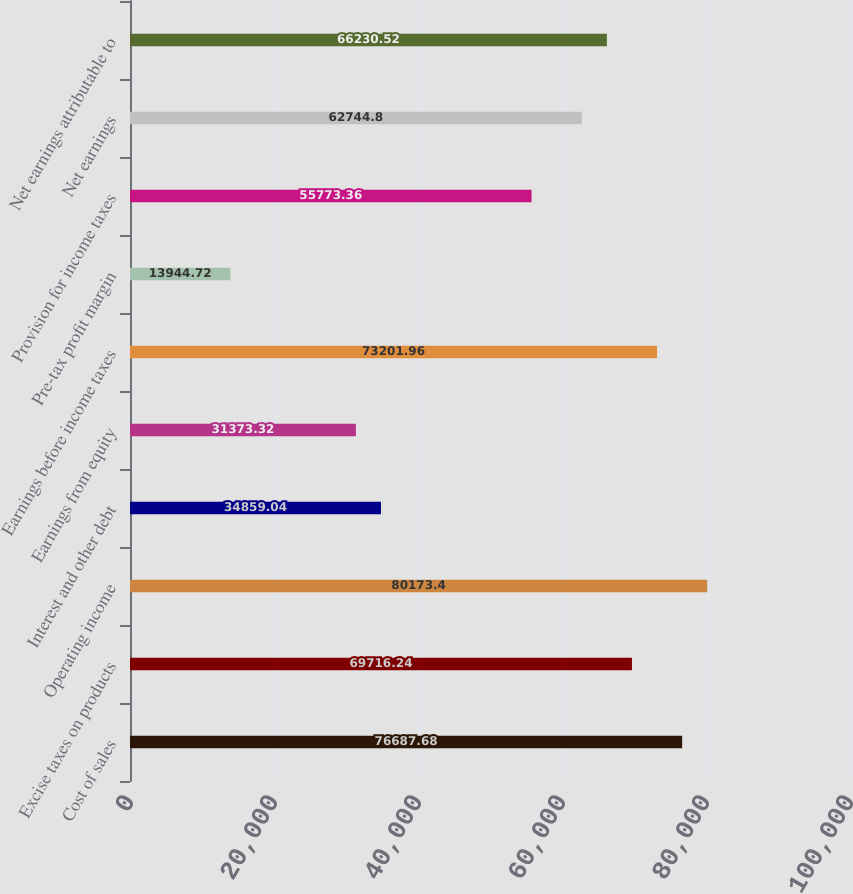<chart> <loc_0><loc_0><loc_500><loc_500><bar_chart><fcel>Cost of sales<fcel>Excise taxes on products<fcel>Operating income<fcel>Interest and other debt<fcel>Earnings from equity<fcel>Earnings before income taxes<fcel>Pre-tax profit margin<fcel>Provision for income taxes<fcel>Net earnings<fcel>Net earnings attributable to<nl><fcel>76687.7<fcel>69716.2<fcel>80173.4<fcel>34859<fcel>31373.3<fcel>73202<fcel>13944.7<fcel>55773.4<fcel>62744.8<fcel>66230.5<nl></chart> 